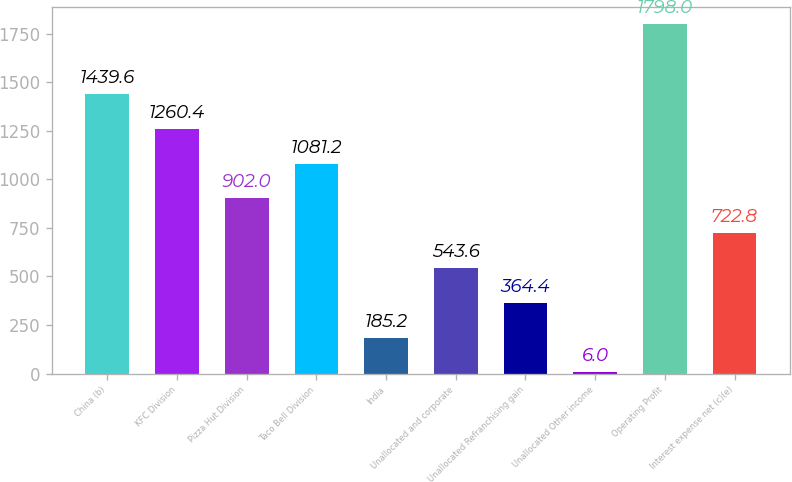Convert chart. <chart><loc_0><loc_0><loc_500><loc_500><bar_chart><fcel>China (b)<fcel>KFC Division<fcel>Pizza Hut Division<fcel>Taco Bell Division<fcel>India<fcel>Unallocated and corporate<fcel>Unallocated Refranchising gain<fcel>Unallocated Other income<fcel>Operating Profit<fcel>Interest expense net (c)(e)<nl><fcel>1439.6<fcel>1260.4<fcel>902<fcel>1081.2<fcel>185.2<fcel>543.6<fcel>364.4<fcel>6<fcel>1798<fcel>722.8<nl></chart> 